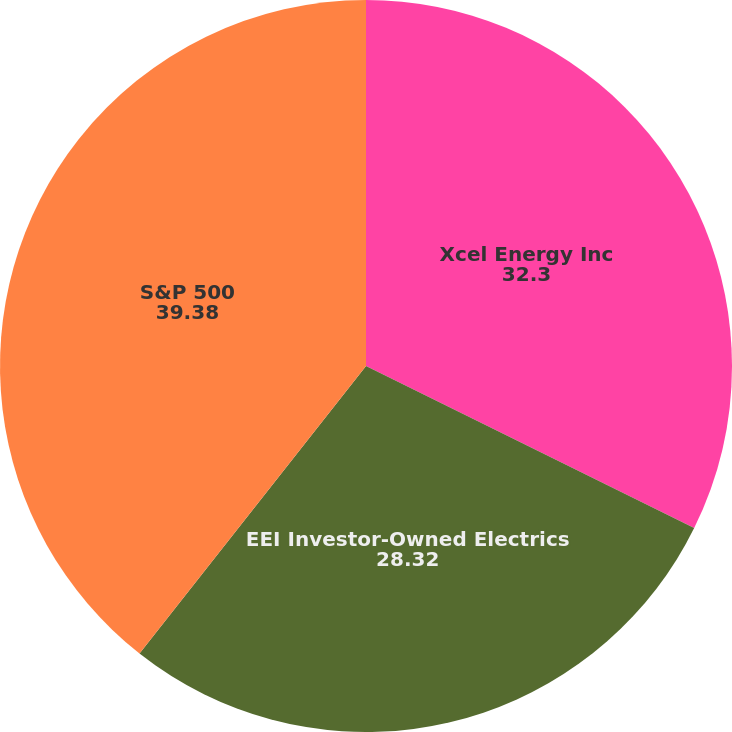Convert chart to OTSL. <chart><loc_0><loc_0><loc_500><loc_500><pie_chart><fcel>Xcel Energy Inc<fcel>EEI Investor-Owned Electrics<fcel>S&P 500<nl><fcel>32.3%<fcel>28.32%<fcel>39.38%<nl></chart> 